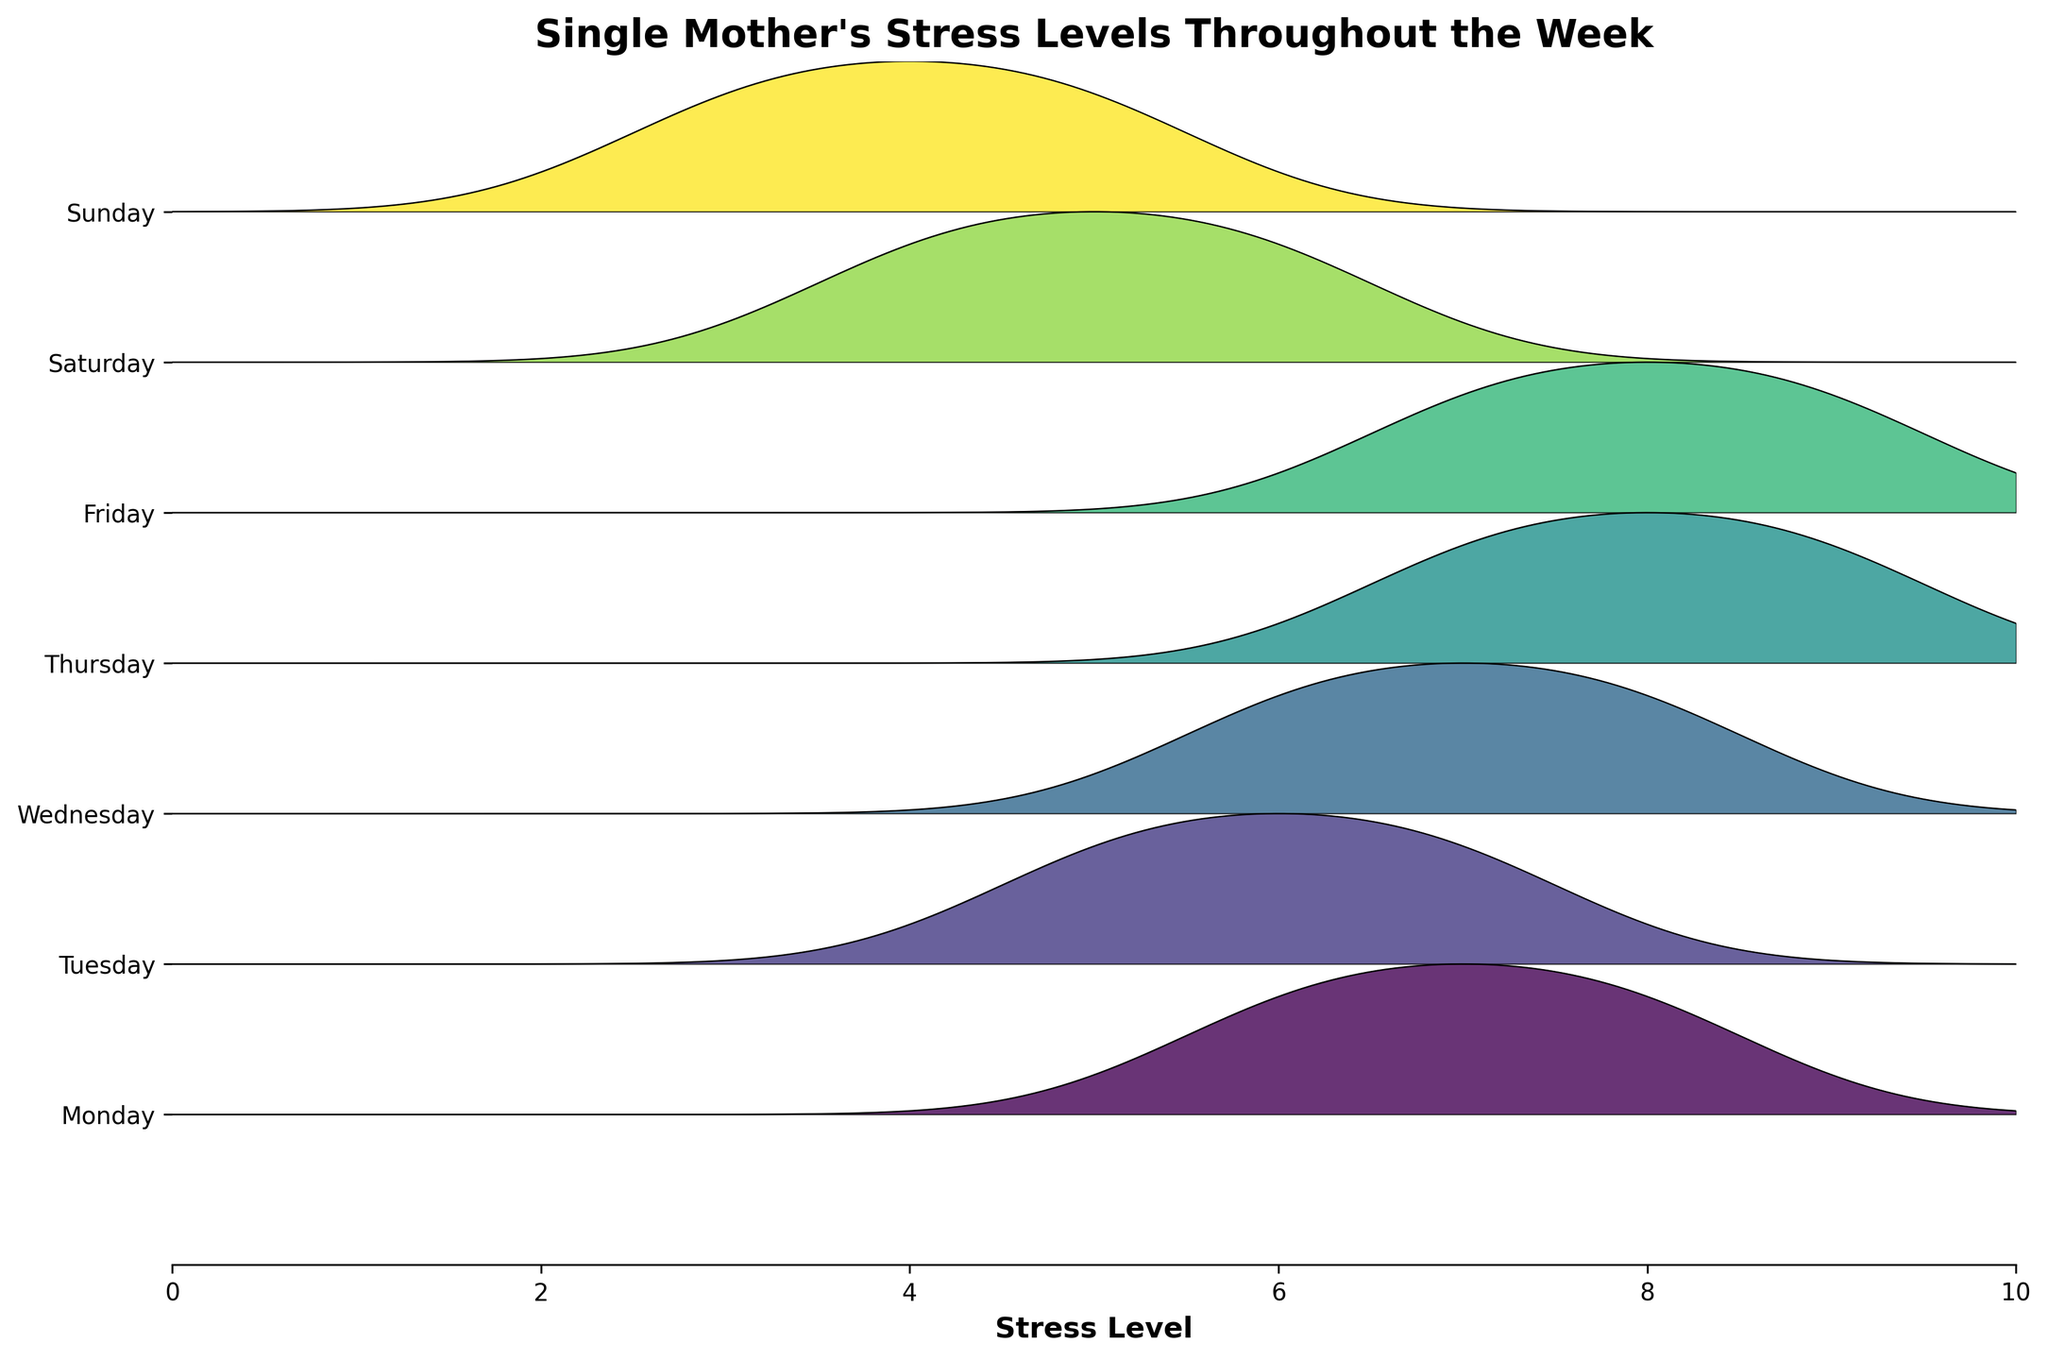What is the title of the plot? The title of the plot is usually found at the top and provides a summary of the graph's purpose. Here, it tells us that the plot is about the stress levels of single mothers throughout the week.
Answer: Single Mother's Stress Levels Throughout the Week Which day seems to have the highest stress levels overall? To determine this, look at the height of the ridgeline plots. The taller the plot, the higher the stress levels indicated. By comparing all days, we can see that Thursday appears to have the tallest ridges, meaning the highest stress levels.
Answer: Thursday What is the general trend of stress levels from weekdays to weekends? Weekdays like Monday to Friday show higher average stress levels, while weekends (Saturday and Sunday) show lower stress levels. This can be observed by the peak heights and how the distributions are denser at higher values on weekdays compared to weekends.
Answer: Stress levels are higher on weekdays and lower on weekends Are there any days where stress levels decrease significantly? By examining the heights and spread of the ridgeline plots, we can see a significant drop in stress levels from Friday to Saturday and also from Saturday to Sunday. This is visible as the peaks of Saturday and Sunday are much lower compared to Friday.
Answer: From Friday to Saturday and from Saturday to Sunday What's the range of stress levels for Wednesday? The range can be found by looking at the spread of the ridgeline for Wednesday. Stress levels on Wednesday range from lower values (around 6) to higher values (around 8), indicated by the distribution's spread and density.
Answer: 6 - 8 Comparing Monday and Tuesday, which day has a higher peak in stress levels? By comparing the highest points of the distributions, Monday has a higher peak compared to Tuesday. This means that the stress levels reached higher values more frequently on Monday.
Answer: Monday Which day shows the least variability in stress levels? Variability can be inferred from the width of the ridgeline plots. Narrower distributions indicate less variability. Sunday shows the least variability as its ridgeline is narrowest, reflecting concentrated stress levels around a smaller range of values.
Answer: Sunday During what part of the week are stress levels increasing the most rapidly? Look for the days where the peak values and spread show a steep increase. Between Tuesday and Wednesday, as well as from Wednesday to Thursday, we see a rapid increase in stress levels reflected by the rising peak heights and densities in the plots.
Answer: Tuesday to Wednesday and Wednesday to Thursday Comparing the weekends, which day has higher stress levels on average? By evaluating the height and spread of the ridgeline plots, Saturday shows higher stress levels on average compared to Sunday. This is seen in the taller and denser distribution of Saturday.
Answer: Saturday What does the stress distribution for Thursday look like compared to other days? The distribution for Thursday is tall and relatively wide, indicating high stress levels compared to other days. The height of the distribution suggests that stress levels on Thursday are higher than on any other day.
Answer: Tall and relatively wide, indicating high stress levels 